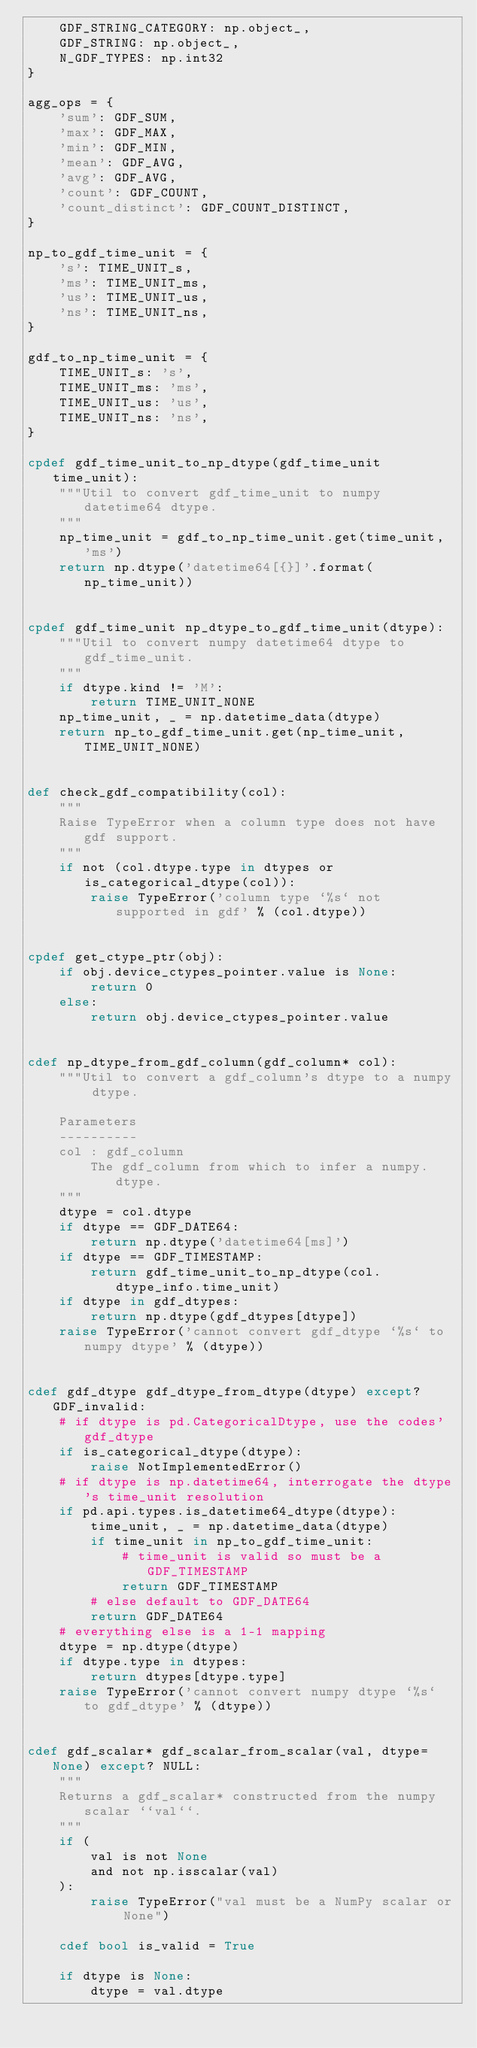Convert code to text. <code><loc_0><loc_0><loc_500><loc_500><_Cython_>    GDF_STRING_CATEGORY: np.object_,
    GDF_STRING: np.object_,
    N_GDF_TYPES: np.int32
}

agg_ops = {
    'sum': GDF_SUM,
    'max': GDF_MAX,
    'min': GDF_MIN,
    'mean': GDF_AVG,
    'avg': GDF_AVG,
    'count': GDF_COUNT,
    'count_distinct': GDF_COUNT_DISTINCT,
}

np_to_gdf_time_unit = {
    's': TIME_UNIT_s,
    'ms': TIME_UNIT_ms,
    'us': TIME_UNIT_us,
    'ns': TIME_UNIT_ns,
}

gdf_to_np_time_unit = {
    TIME_UNIT_s: 's',
    TIME_UNIT_ms: 'ms',
    TIME_UNIT_us: 'us',
    TIME_UNIT_ns: 'ns',
}

cpdef gdf_time_unit_to_np_dtype(gdf_time_unit time_unit):
    """Util to convert gdf_time_unit to numpy datetime64 dtype.
    """
    np_time_unit = gdf_to_np_time_unit.get(time_unit, 'ms')
    return np.dtype('datetime64[{}]'.format(np_time_unit))


cpdef gdf_time_unit np_dtype_to_gdf_time_unit(dtype):
    """Util to convert numpy datetime64 dtype to gdf_time_unit.
    """
    if dtype.kind != 'M':
        return TIME_UNIT_NONE
    np_time_unit, _ = np.datetime_data(dtype)
    return np_to_gdf_time_unit.get(np_time_unit, TIME_UNIT_NONE)


def check_gdf_compatibility(col):
    """
    Raise TypeError when a column type does not have gdf support.
    """
    if not (col.dtype.type in dtypes or is_categorical_dtype(col)):
        raise TypeError('column type `%s` not supported in gdf' % (col.dtype))


cpdef get_ctype_ptr(obj):
    if obj.device_ctypes_pointer.value is None:
        return 0
    else:
        return obj.device_ctypes_pointer.value


cdef np_dtype_from_gdf_column(gdf_column* col):
    """Util to convert a gdf_column's dtype to a numpy dtype.

    Parameters
    ----------
    col : gdf_column
        The gdf_column from which to infer a numpy.dtype.
    """
    dtype = col.dtype
    if dtype == GDF_DATE64:
        return np.dtype('datetime64[ms]')
    if dtype == GDF_TIMESTAMP:
        return gdf_time_unit_to_np_dtype(col.dtype_info.time_unit)
    if dtype in gdf_dtypes:
        return np.dtype(gdf_dtypes[dtype])
    raise TypeError('cannot convert gdf_dtype `%s` to numpy dtype' % (dtype))


cdef gdf_dtype gdf_dtype_from_dtype(dtype) except? GDF_invalid:
    # if dtype is pd.CategoricalDtype, use the codes' gdf_dtype
    if is_categorical_dtype(dtype):
        raise NotImplementedError()
    # if dtype is np.datetime64, interrogate the dtype's time_unit resolution
    if pd.api.types.is_datetime64_dtype(dtype):
        time_unit, _ = np.datetime_data(dtype)
        if time_unit in np_to_gdf_time_unit:
            # time_unit is valid so must be a GDF_TIMESTAMP
            return GDF_TIMESTAMP
        # else default to GDF_DATE64
        return GDF_DATE64
    # everything else is a 1-1 mapping
    dtype = np.dtype(dtype)
    if dtype.type in dtypes:
        return dtypes[dtype.type]
    raise TypeError('cannot convert numpy dtype `%s` to gdf_dtype' % (dtype))


cdef gdf_scalar* gdf_scalar_from_scalar(val, dtype=None) except? NULL:
    """
    Returns a gdf_scalar* constructed from the numpy scalar ``val``.
    """
    if (
        val is not None
        and not np.isscalar(val)
    ):
        raise TypeError("val must be a NumPy scalar or None")

    cdef bool is_valid = True

    if dtype is None:
        dtype = val.dtype
</code> 